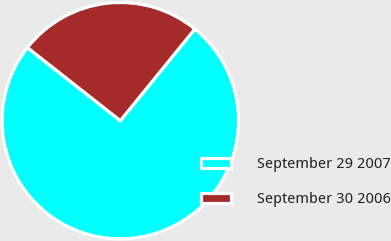<chart> <loc_0><loc_0><loc_500><loc_500><pie_chart><fcel>September 29 2007<fcel>September 30 2006<nl><fcel>74.74%<fcel>25.26%<nl></chart> 